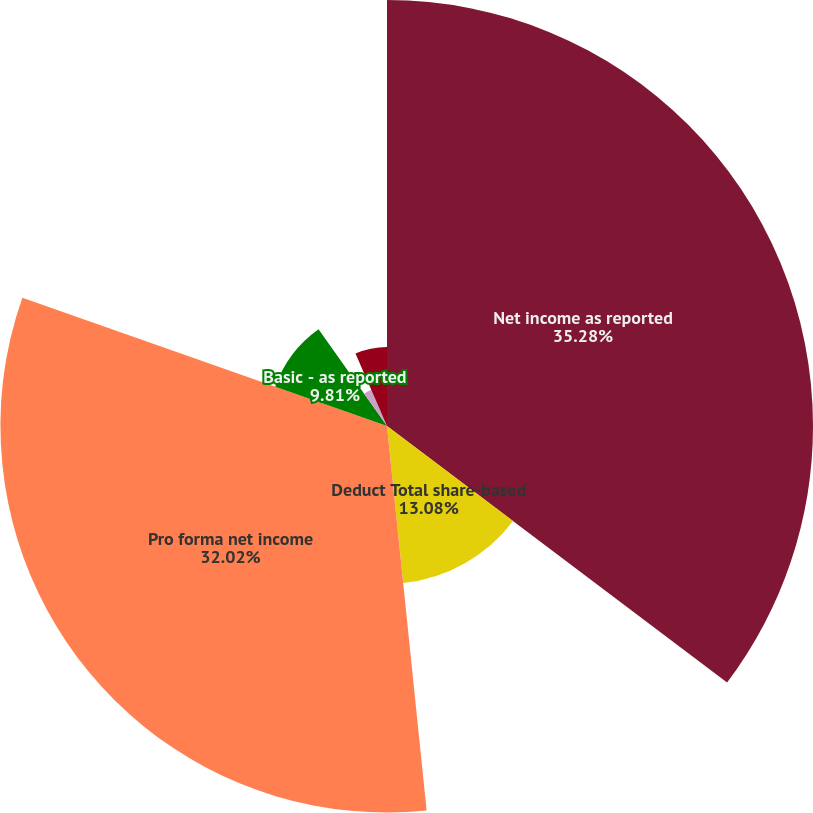<chart> <loc_0><loc_0><loc_500><loc_500><pie_chart><fcel>Net income as reported<fcel>Deduct Total share-based<fcel>Pro forma net income<fcel>Basic - as reported<fcel>Basic - pro forma<fcel>Diluted - as reported<fcel>Diluted - pro forma<nl><fcel>35.29%<fcel>13.08%<fcel>32.02%<fcel>9.81%<fcel>3.27%<fcel>6.54%<fcel>0.0%<nl></chart> 